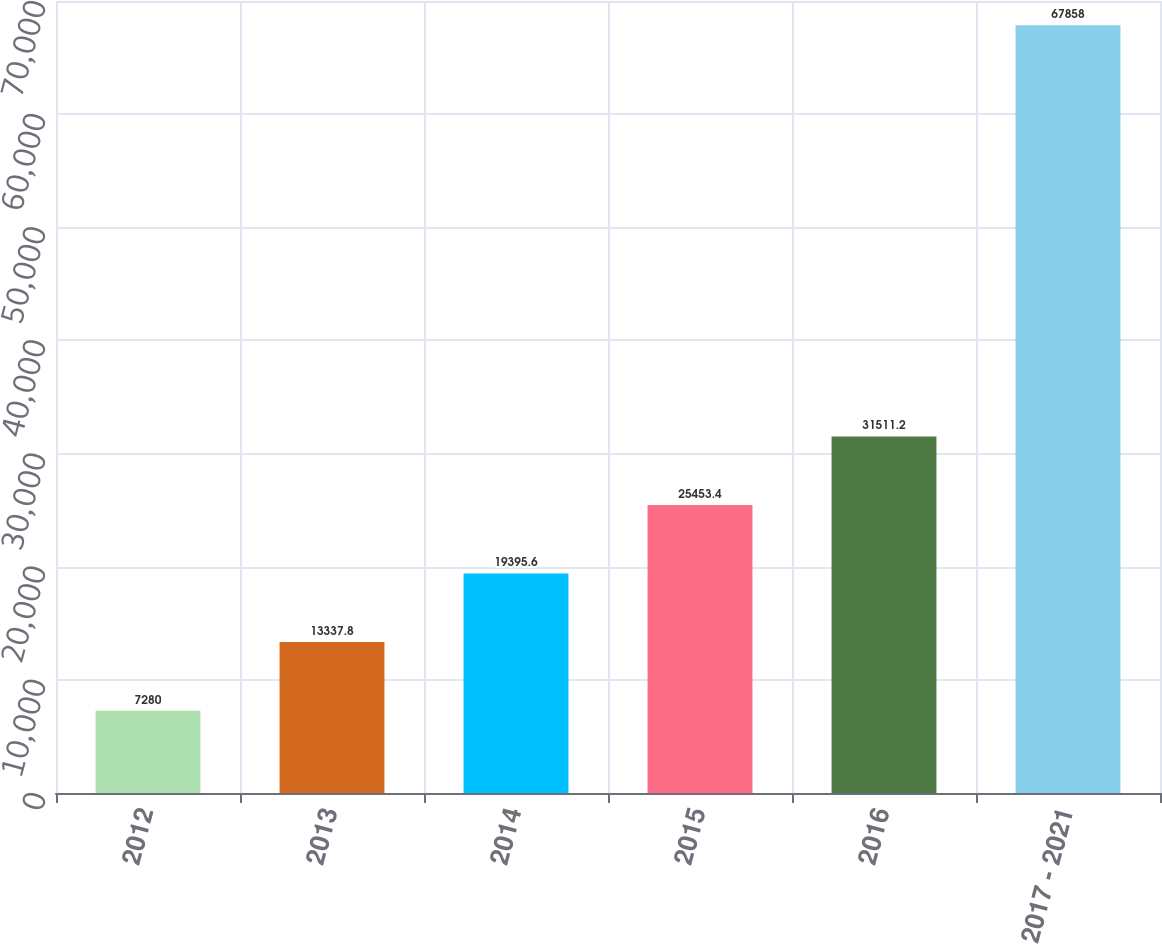Convert chart to OTSL. <chart><loc_0><loc_0><loc_500><loc_500><bar_chart><fcel>2012<fcel>2013<fcel>2014<fcel>2015<fcel>2016<fcel>2017 - 2021<nl><fcel>7280<fcel>13337.8<fcel>19395.6<fcel>25453.4<fcel>31511.2<fcel>67858<nl></chart> 